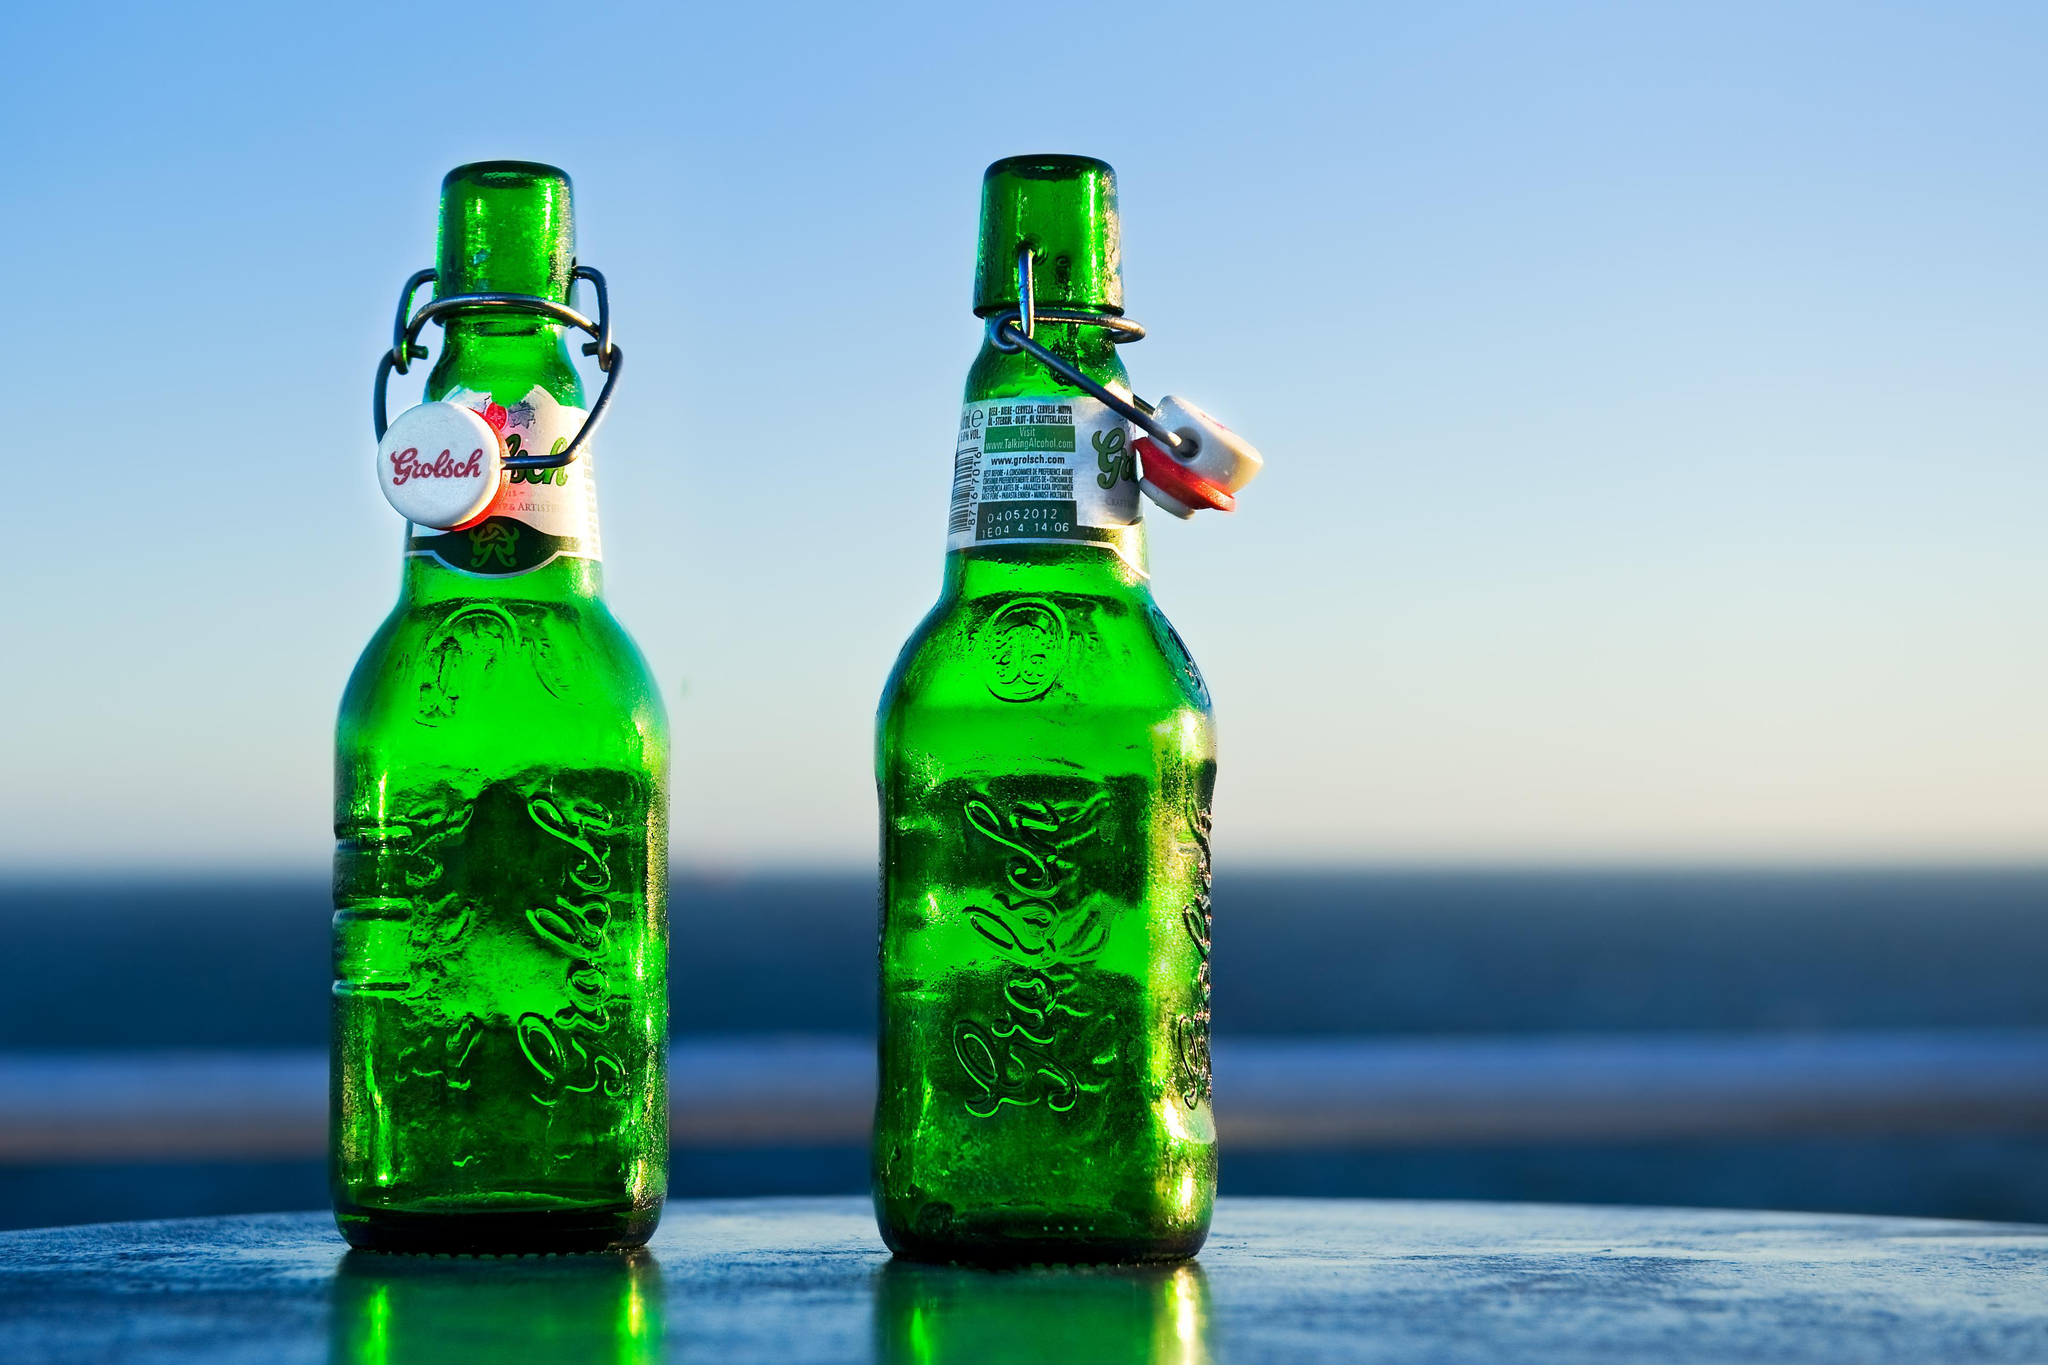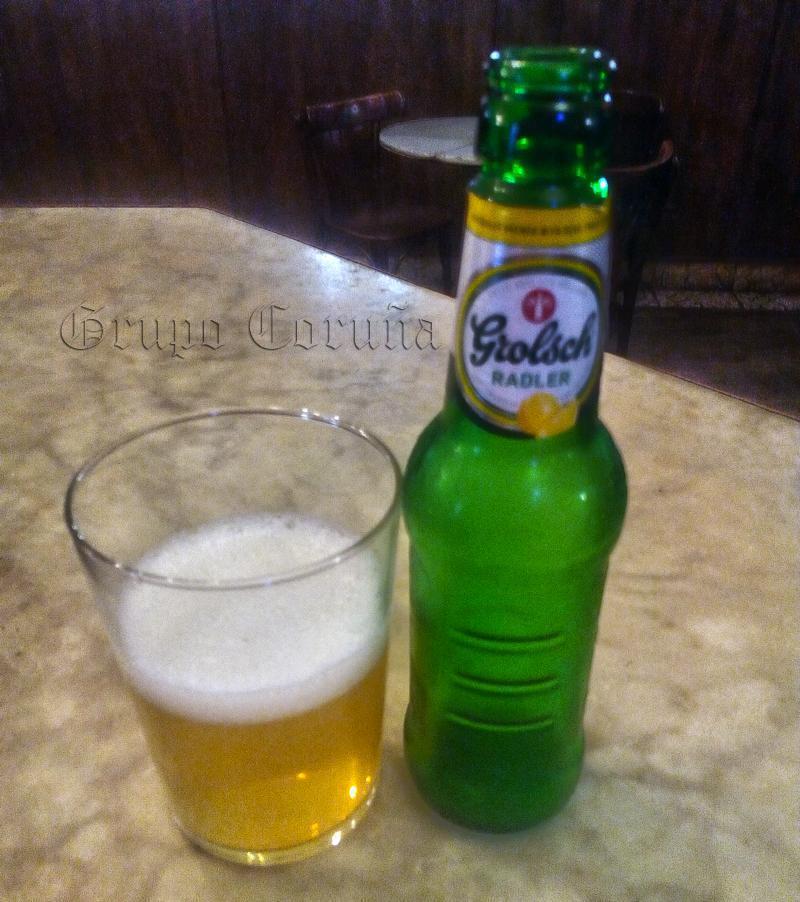The first image is the image on the left, the second image is the image on the right. For the images displayed, is the sentence "Two green bottles are sitting near some ice." factually correct? Answer yes or no. No. The first image is the image on the left, the second image is the image on the right. For the images shown, is this caption "Neither individual image includes more than two bottles." true? Answer yes or no. Yes. 